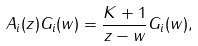Convert formula to latex. <formula><loc_0><loc_0><loc_500><loc_500>A _ { i } ( z ) G _ { i } ( w ) = \frac { K + 1 } { z - w } G _ { i } ( w ) ,</formula> 